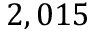Convert formula to latex. <formula><loc_0><loc_0><loc_500><loc_500>2 , 0 1 5</formula> 